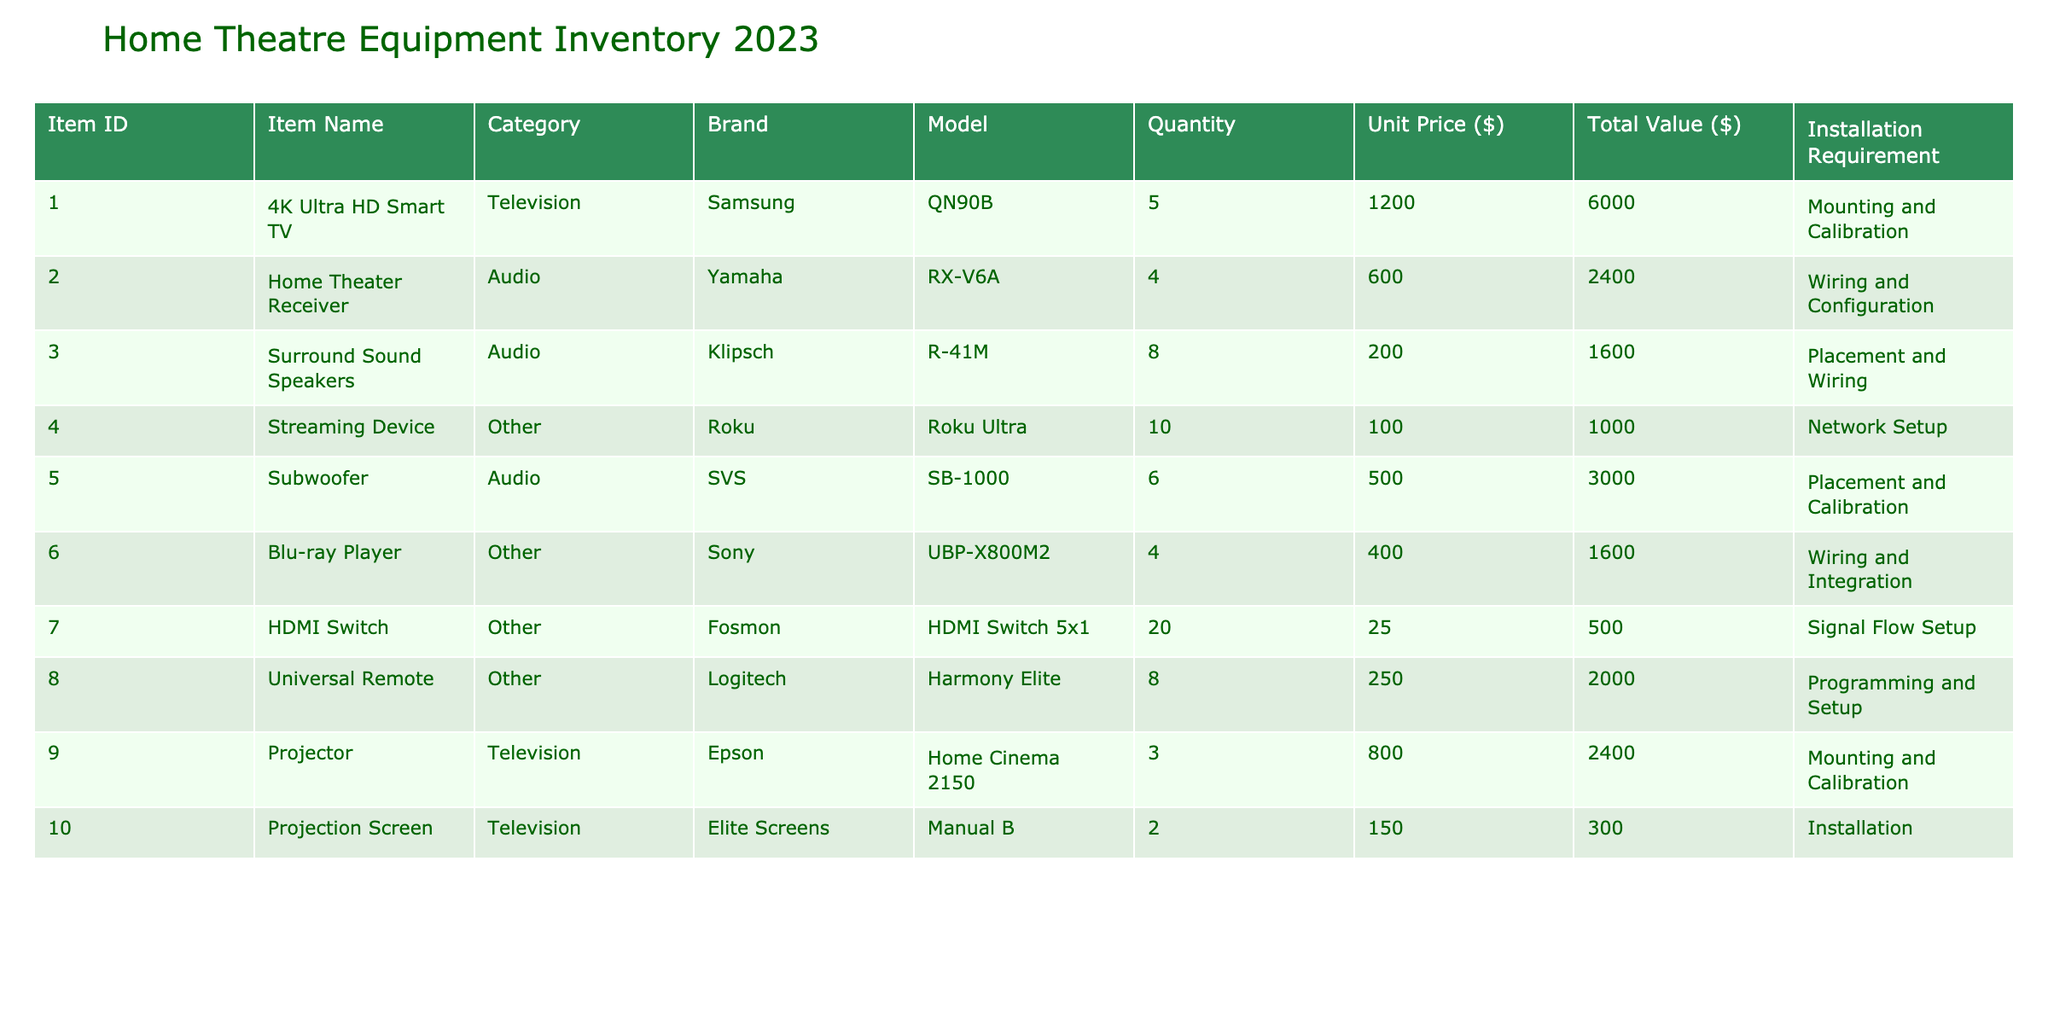What is the total value of the Surround Sound Speakers? The total value of an item can be found by looking at the "Total Value ($)" column for the "Surround Sound Speakers." It shows 1600.
Answer: 1600 How many Subwoofers are available? The "Quantity" column for "Subwoofer" shows 6 available items.
Answer: 6 Which brand has the highest unit price among the listed items? To find the brand with the highest unit price, we check the "Unit Price ($)" column and see that the "4K Ultra HD Smart TV" from Samsung has the highest unit price of 1200.
Answer: Samsung Is there more than one type of audio equipment in the inventory? Yes, there are two types of audio equipment listed: "Home Theater Receiver" and "Surround Sound Speakers."
Answer: Yes What is the combined total value of the televisions in the inventory? The total values for televisions are: 6000 (for 4K Ultra HD Smart TV) and 2400 (for the projector). Adding these gives: 6000 + 2400 = 8400.
Answer: 8400 Do any items require "Wiring and Integration" for installation? Yes, the "Blu-ray Player" requires "Wiring and Integration."
Answer: Yes How many items have a total value greater than 2000? The items exceeding a total value of 2000 are: "4K Ultra HD Smart TV," "Home Theater Receiver," "Subwoofer," "Projector," and "Universal Remote" totaling 5 items.
Answer: 5 What is the average unit price of all items in the inventory? To find the average unit price, we sum all the unit prices (1200 + 600 + 200 + 100 + 500 + 400 + 25 + 250 + 800 + 150 = 3825) and divide by the number of items (10), which is 3825 / 10 = 382.5.
Answer: 382.5 Which item has the lowest quantity available? Looking through the "Quantity" column, the "Projection Screen" has the lowest quantity, which is 2.
Answer: Projection Screen 